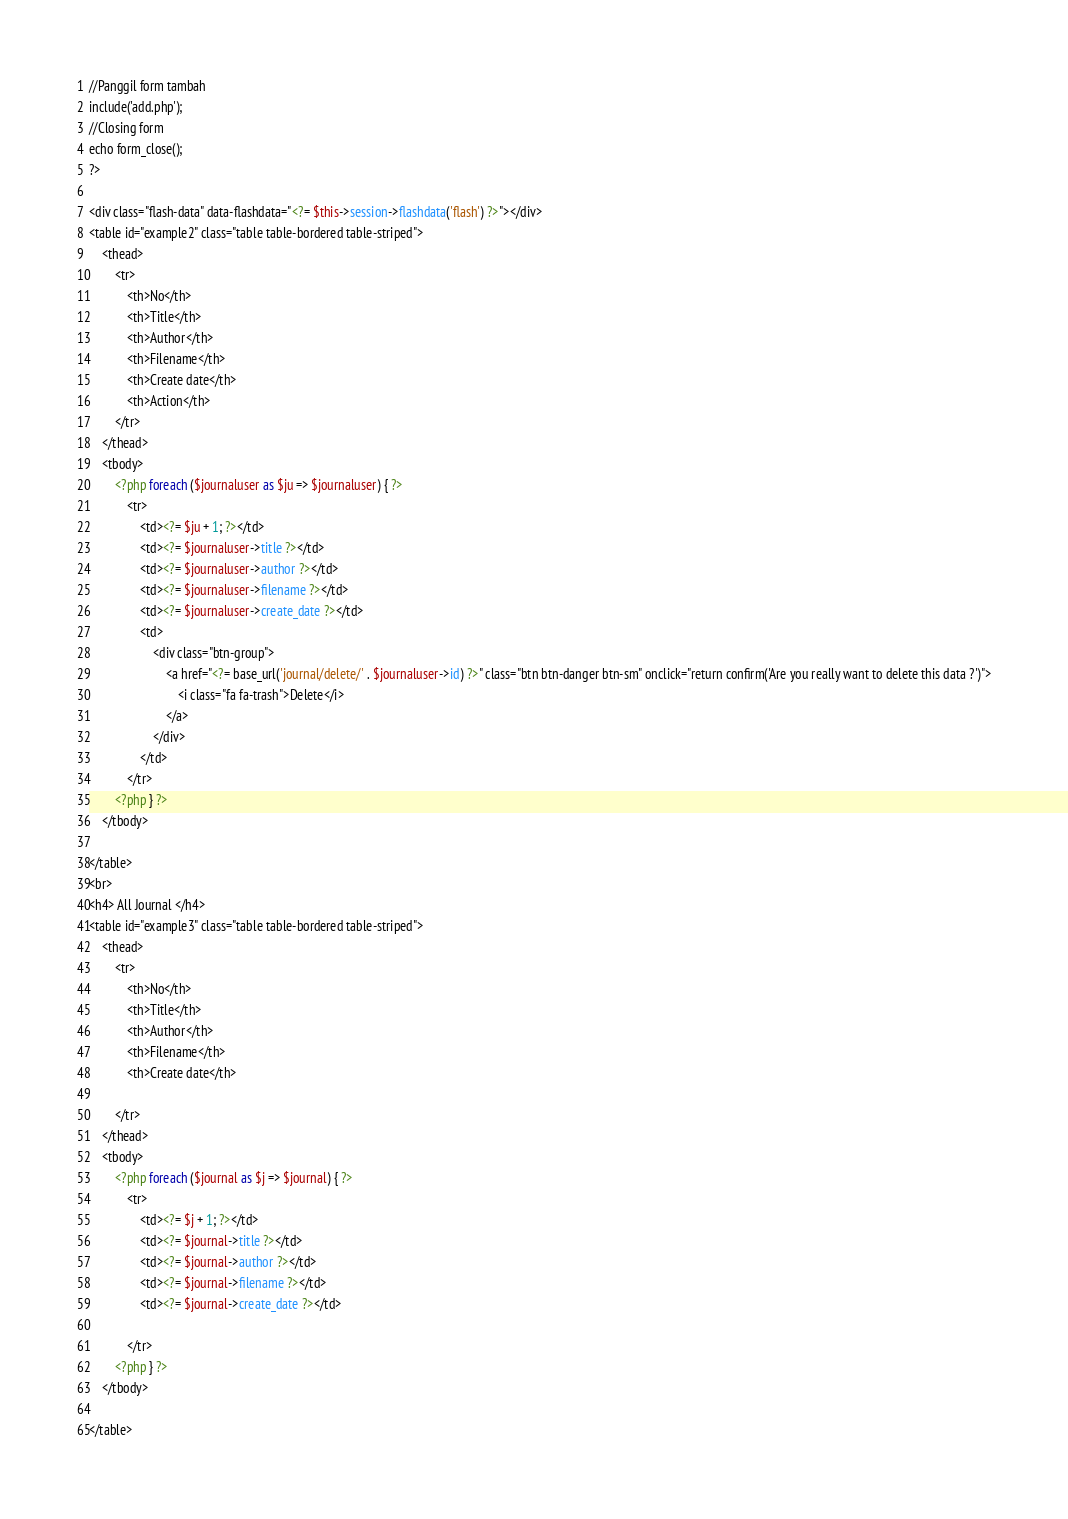Convert code to text. <code><loc_0><loc_0><loc_500><loc_500><_PHP_>//Panggil form tambah
include('add.php');
//Closing form
echo form_close();
?>

<div class="flash-data" data-flashdata="<?= $this->session->flashdata('flash') ?>"></div>
<table id="example2" class="table table-bordered table-striped">
    <thead>
        <tr>
            <th>No</th>
            <th>Title</th>
            <th>Author</th>
            <th>Filename</th>
            <th>Create date</th>
            <th>Action</th>
        </tr>
    </thead>
    <tbody>
        <?php foreach ($journaluser as $ju => $journaluser) { ?>
            <tr>
                <td><?= $ju + 1; ?></td>
                <td><?= $journaluser->title ?></td>
                <td><?= $journaluser->author ?></td>
                <td><?= $journaluser->filename ?></td>
                <td><?= $journaluser->create_date ?></td>
                <td>
                    <div class="btn-group">
                        <a href="<?= base_url('journal/delete/' . $journaluser->id) ?>" class="btn btn-danger btn-sm" onclick="return confirm('Are you really want to delete this data ?')">
                            <i class="fa fa-trash">Delete</i>
                        </a>
                    </div>
                </td>
            </tr>
        <?php } ?>
    </tbody>

</table>
<br>
<h4> All Journal </h4>
<table id="example3" class="table table-bordered table-striped">
    <thead>
        <tr>
            <th>No</th>
            <th>Title</th>
            <th>Author</th>
            <th>Filename</th>
            <th>Create date</th>

        </tr>
    </thead>
    <tbody>
        <?php foreach ($journal as $j => $journal) { ?>
            <tr>
                <td><?= $j + 1; ?></td>
                <td><?= $journal->title ?></td>
                <td><?= $journal->author ?></td>
                <td><?= $journal->filename ?></td>
                <td><?= $journal->create_date ?></td>

            </tr>
        <?php } ?>
    </tbody>

</table></code> 